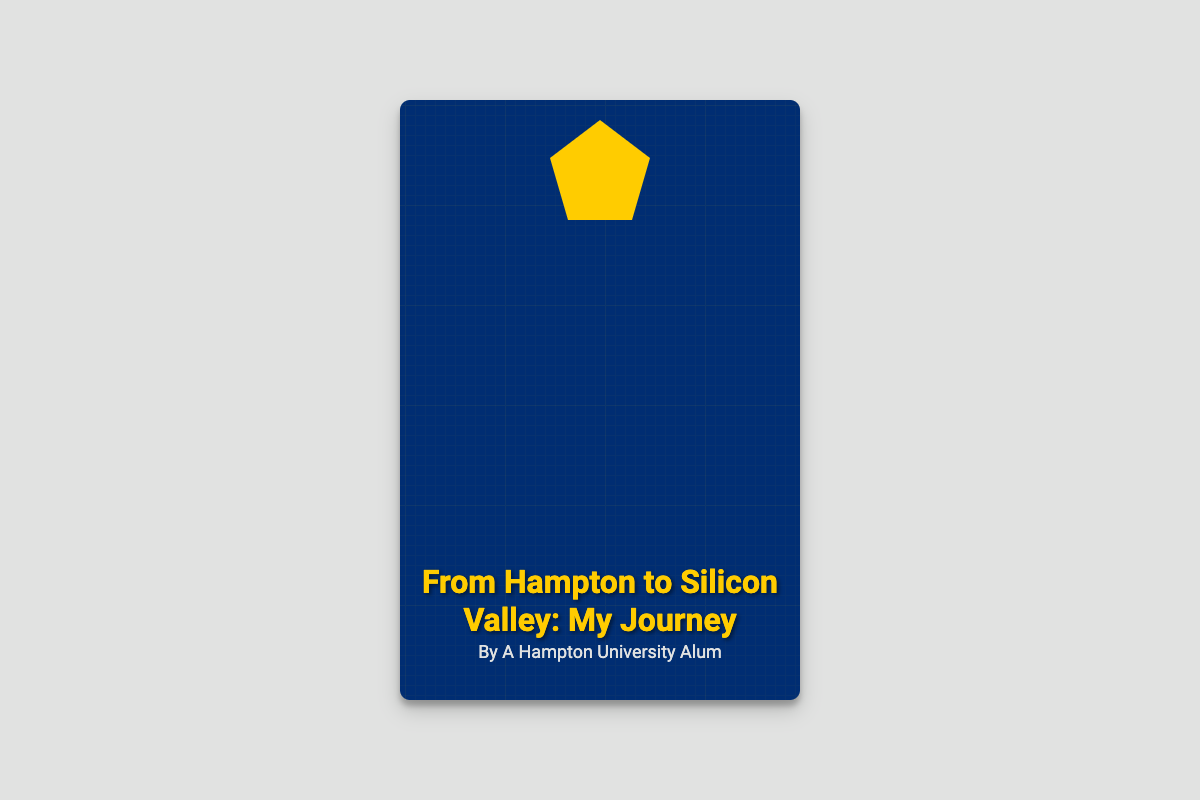What is the title of the book? The title is prominently displayed in a modern font near the center of the cover.
Answer: From Hampton to Silicon Valley: My Journey Who is the author of the book? The author's name is shown at the bottom of the cover.
Answer: A Hampton University Alum What color is the background of the book cover? The background color is indicated in the style section of the code.
Answer: Dark blue What emblem is featured on the cover? The emblem is prominently placed at the top of the cover.
Answer: Hampton University Emblem What element symbolizes modern technology on the cover? The circuit overlay adds a technological aspect to the design.
Answer: Circuit overlay Where is the title positioned on the cover? The title is located towards the bottom of the book cover.
Answer: Bottom What color is the title text? The color of the title is specified within the style settings.
Answer: Yellow What design element is used to create a visual depth in the book cover? The cover features a particular graphic effect that adds depth.
Answer: Box shadow What is the intended audience of the book based on its title? The book seems to target individuals interested in the intersection of education and technology.
Answer: Tech entrepreneurs 